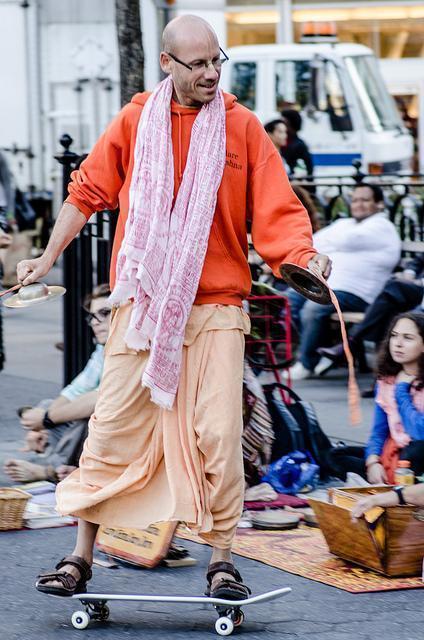In what year was his organization founded in New York City?
From the following set of four choices, select the accurate answer to respond to the question.
Options: 1929, 1902, 1945, 1966. 1966. 